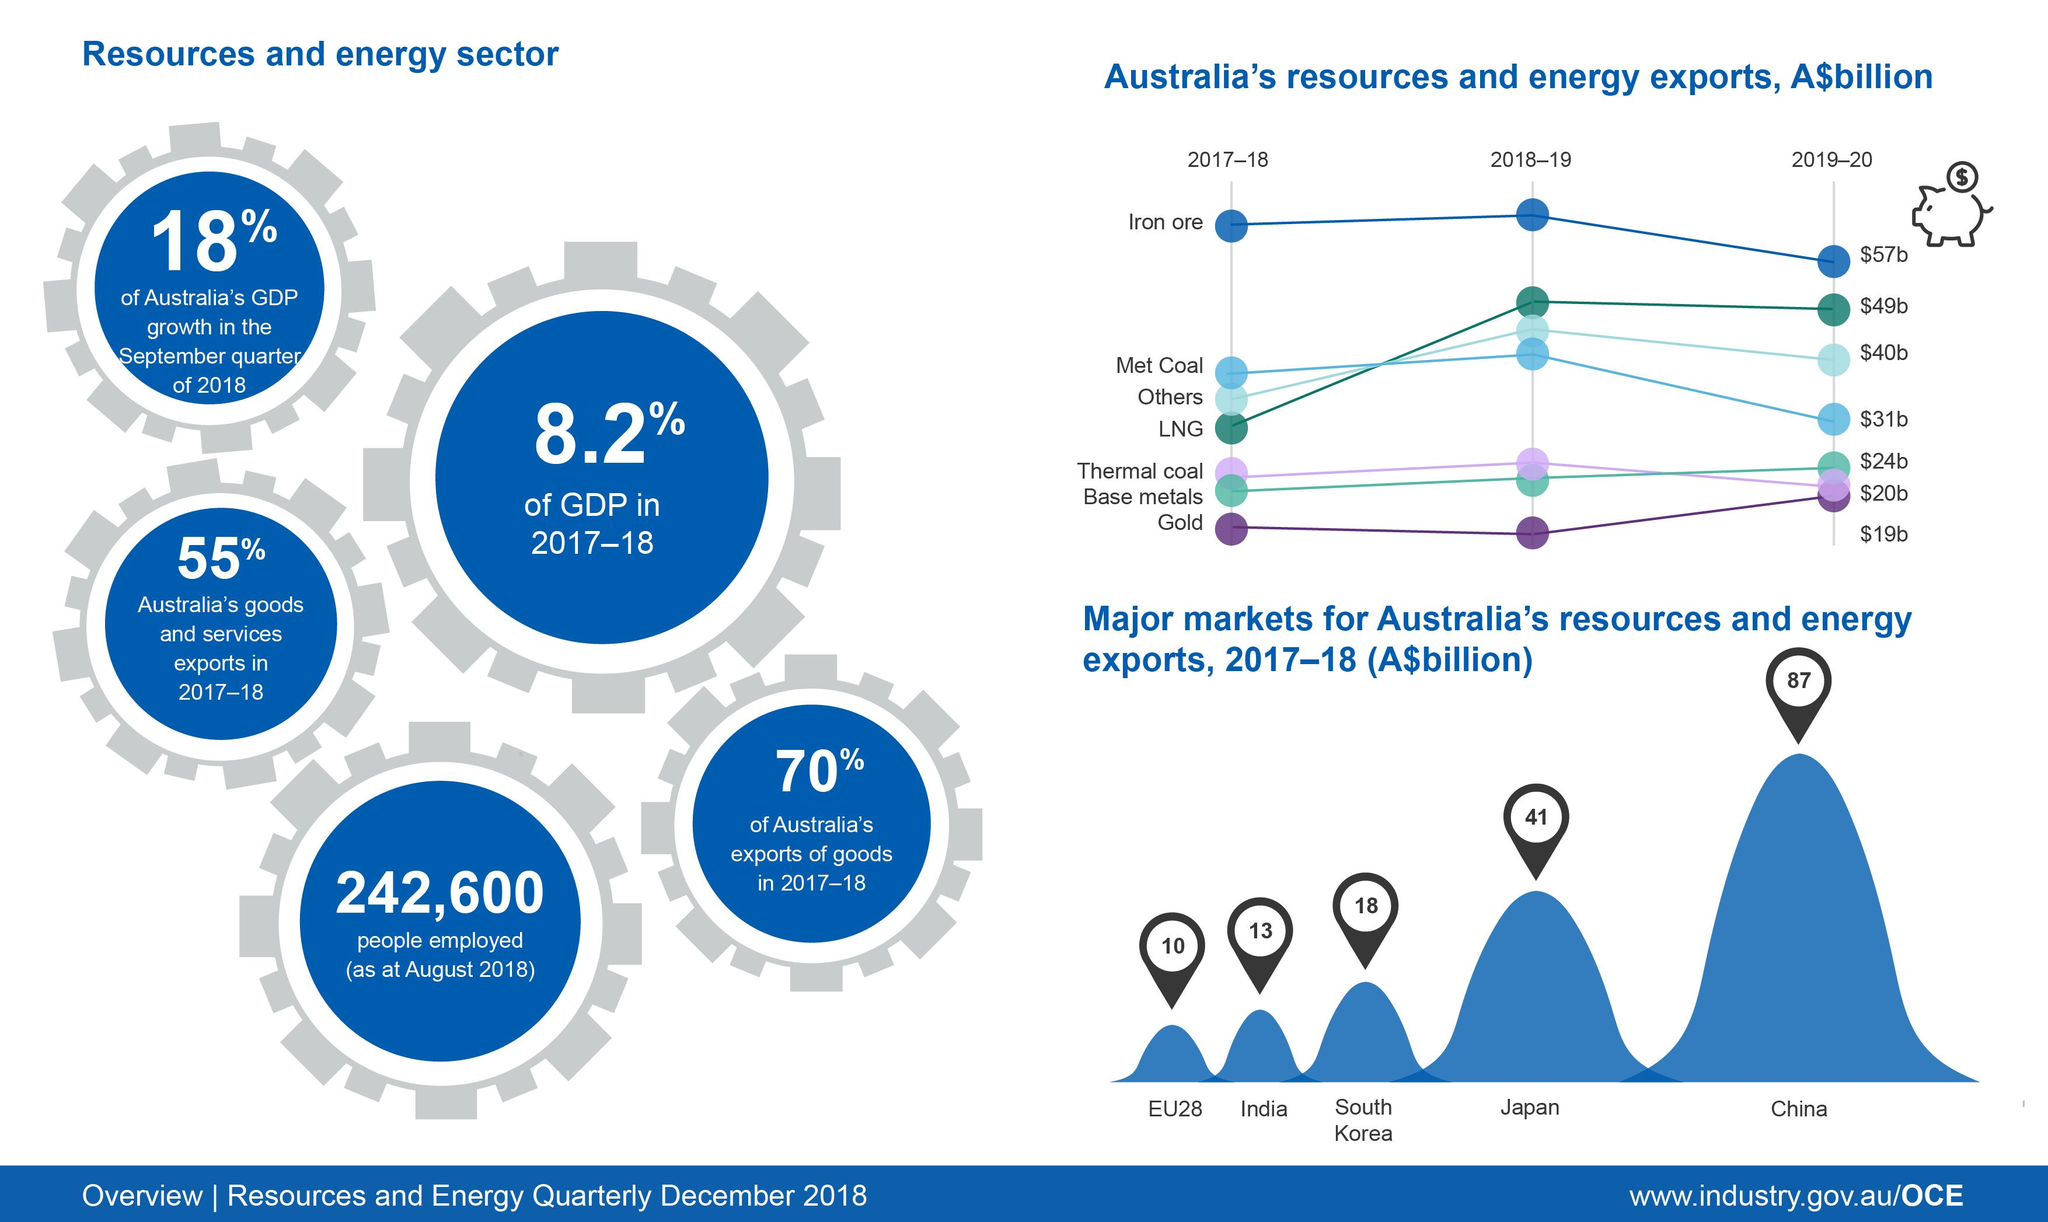Draw attention to some important aspects in this diagram. In the 2017-18 fiscal year, the export value of resources and energy from Australia to India was approximately 13 billion Australian dollars. In 2017-18, the least exported product from Australia was gold. In 2017-18, the Resources & Energy sector contributed approximately 8.2% of Australia's Gross Domestic Product (GDP). Iron ore was the most exported product from Australia in 2018-19. In the year 2017-18, Australia's export value of resources and energy to Japan was approximately 41 billion Australian dollars. 